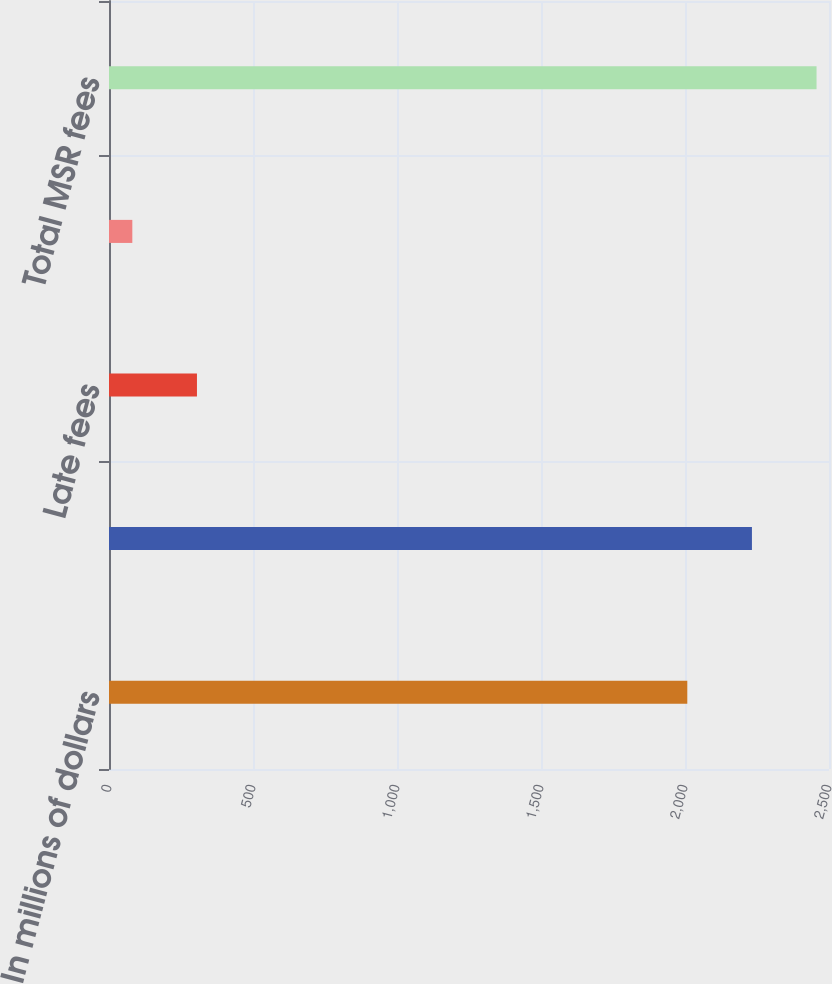Convert chart. <chart><loc_0><loc_0><loc_500><loc_500><bar_chart><fcel>In millions of dollars<fcel>Servicing fees<fcel>Late fees<fcel>Ancillary fees<fcel>Total MSR fees<nl><fcel>2008<fcel>2232.4<fcel>305.4<fcel>81<fcel>2456.8<nl></chart> 